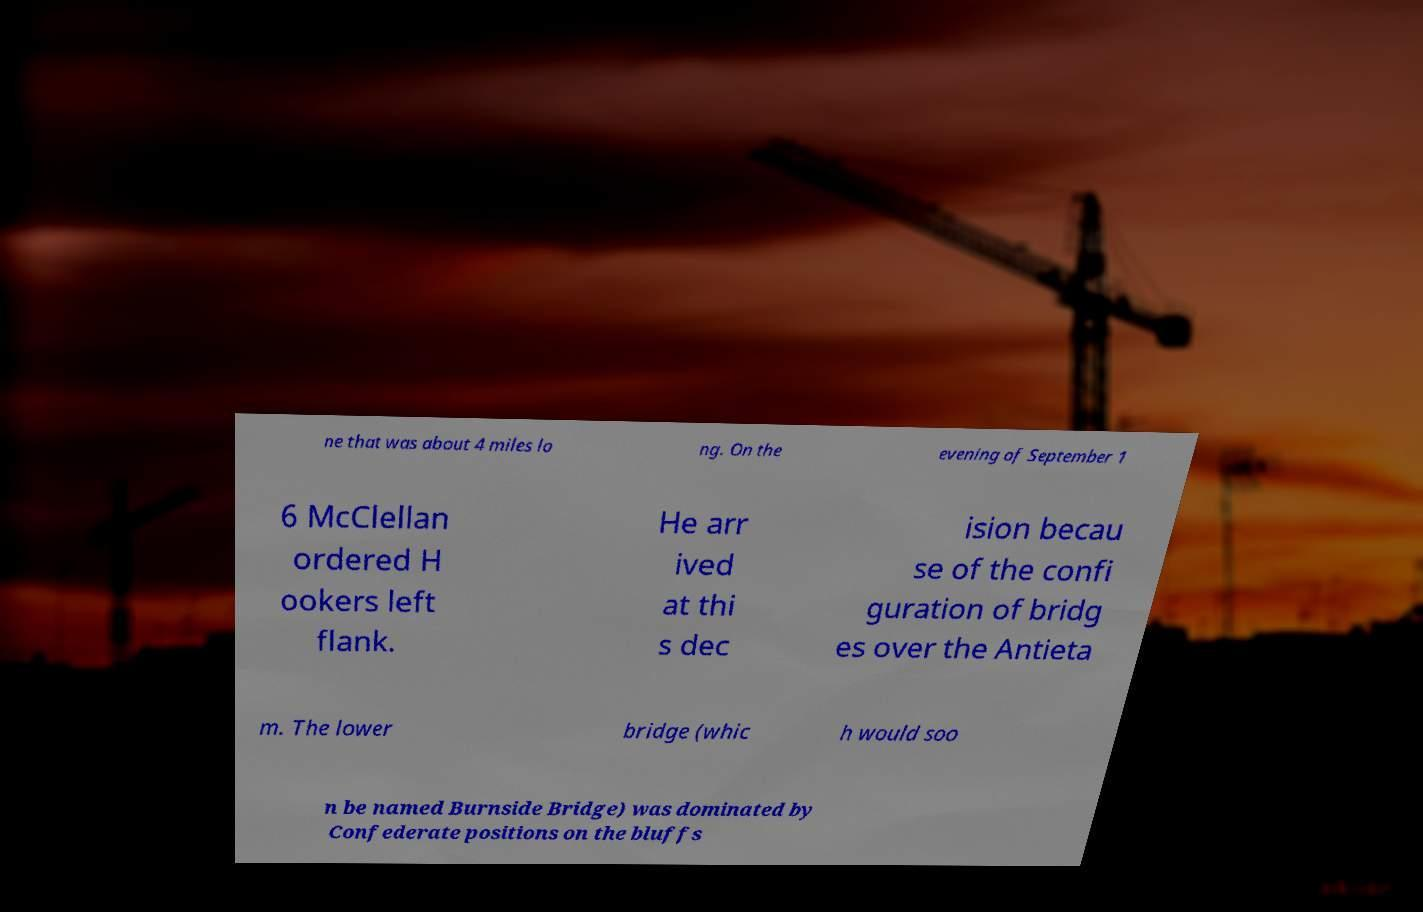Could you extract and type out the text from this image? ne that was about 4 miles lo ng. On the evening of September 1 6 McClellan ordered H ookers left flank. He arr ived at thi s dec ision becau se of the confi guration of bridg es over the Antieta m. The lower bridge (whic h would soo n be named Burnside Bridge) was dominated by Confederate positions on the bluffs 